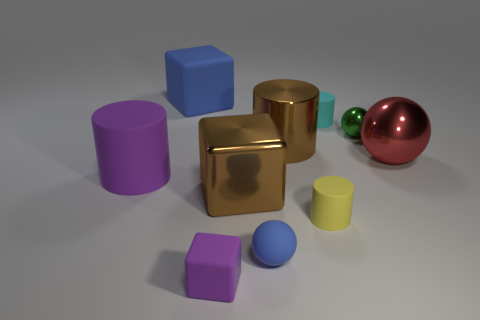Subtract 1 cylinders. How many cylinders are left? 3 Subtract all brown metal cylinders. How many cylinders are left? 3 Subtract all gray cylinders. Subtract all brown balls. How many cylinders are left? 4 Subtract all balls. How many objects are left? 7 Add 1 purple rubber cylinders. How many purple rubber cylinders are left? 2 Add 3 yellow cylinders. How many yellow cylinders exist? 4 Subtract 0 gray cylinders. How many objects are left? 10 Subtract all blue things. Subtract all brown shiny cylinders. How many objects are left? 7 